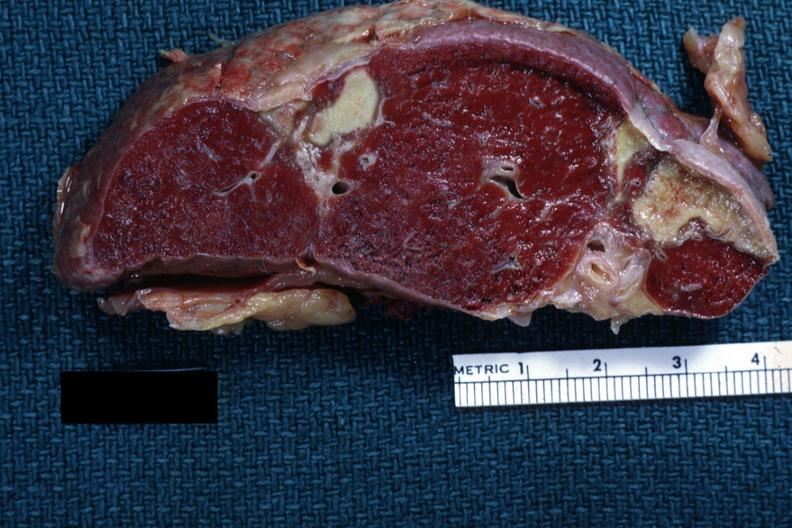how does this image show excellentremote infarct?
Answer the question using a single word or phrase. With yellow centers 